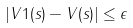Convert formula to latex. <formula><loc_0><loc_0><loc_500><loc_500>| V 1 ( s ) - V ( s ) | \leq \epsilon</formula> 